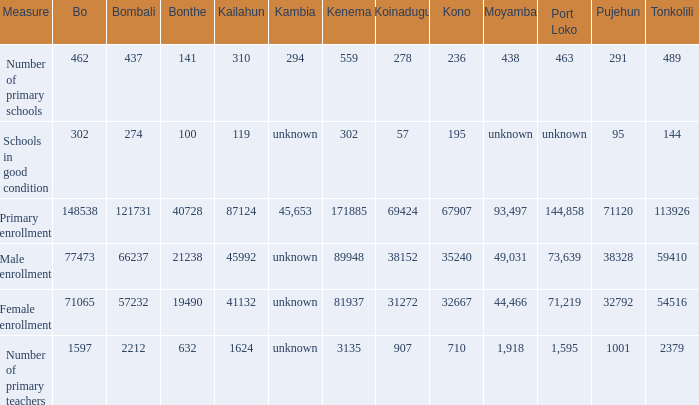What is the least number connected with tonkolili? 144.0. 